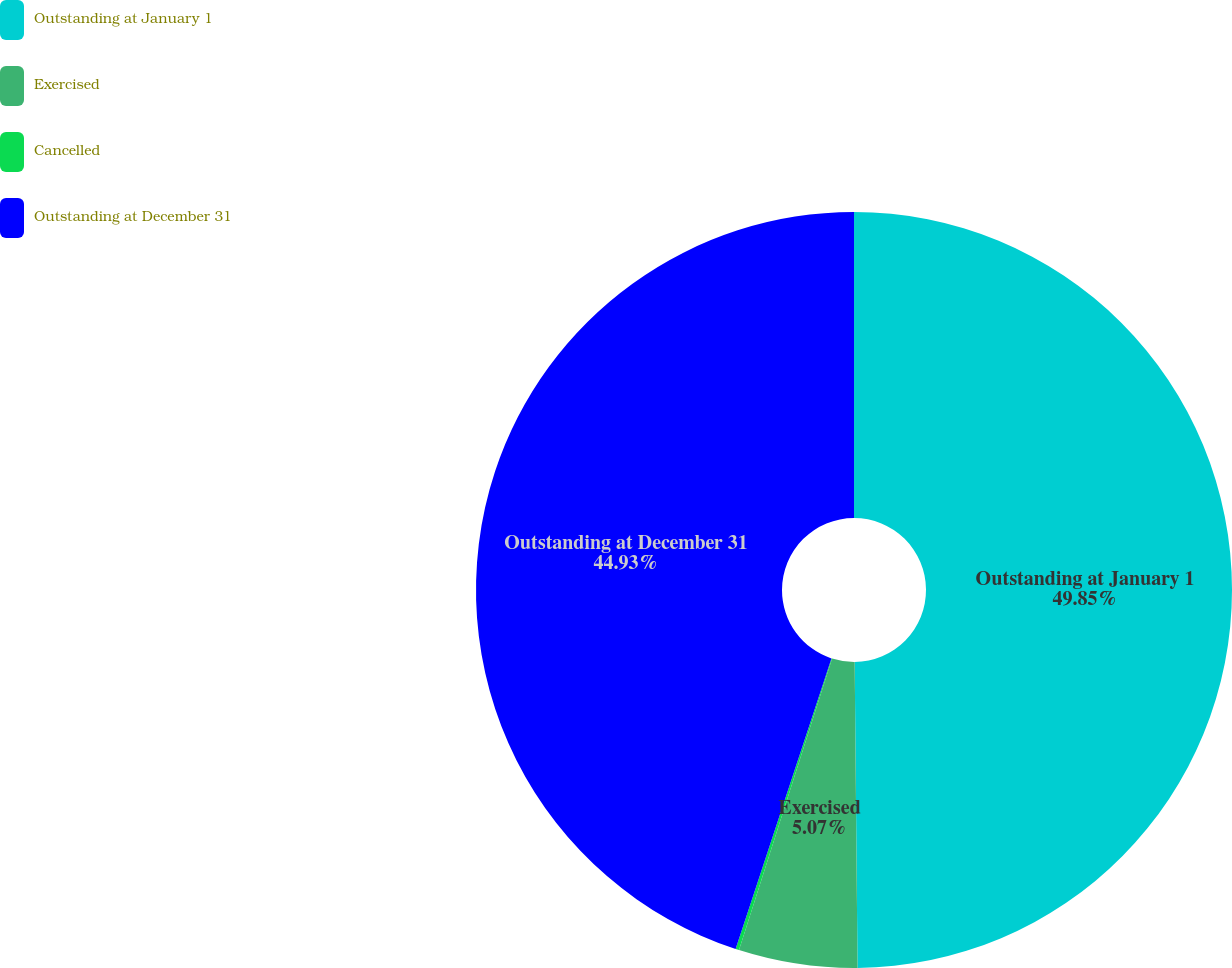<chart> <loc_0><loc_0><loc_500><loc_500><pie_chart><fcel>Outstanding at January 1<fcel>Exercised<fcel>Cancelled<fcel>Outstanding at December 31<nl><fcel>49.85%<fcel>5.07%<fcel>0.15%<fcel>44.93%<nl></chart> 